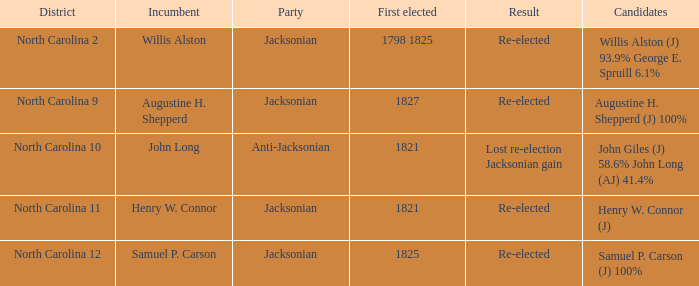Provide the sum of party percentages for willis alston (j) with 93.9% and george e. spruill with 6.1%. 1.0. 